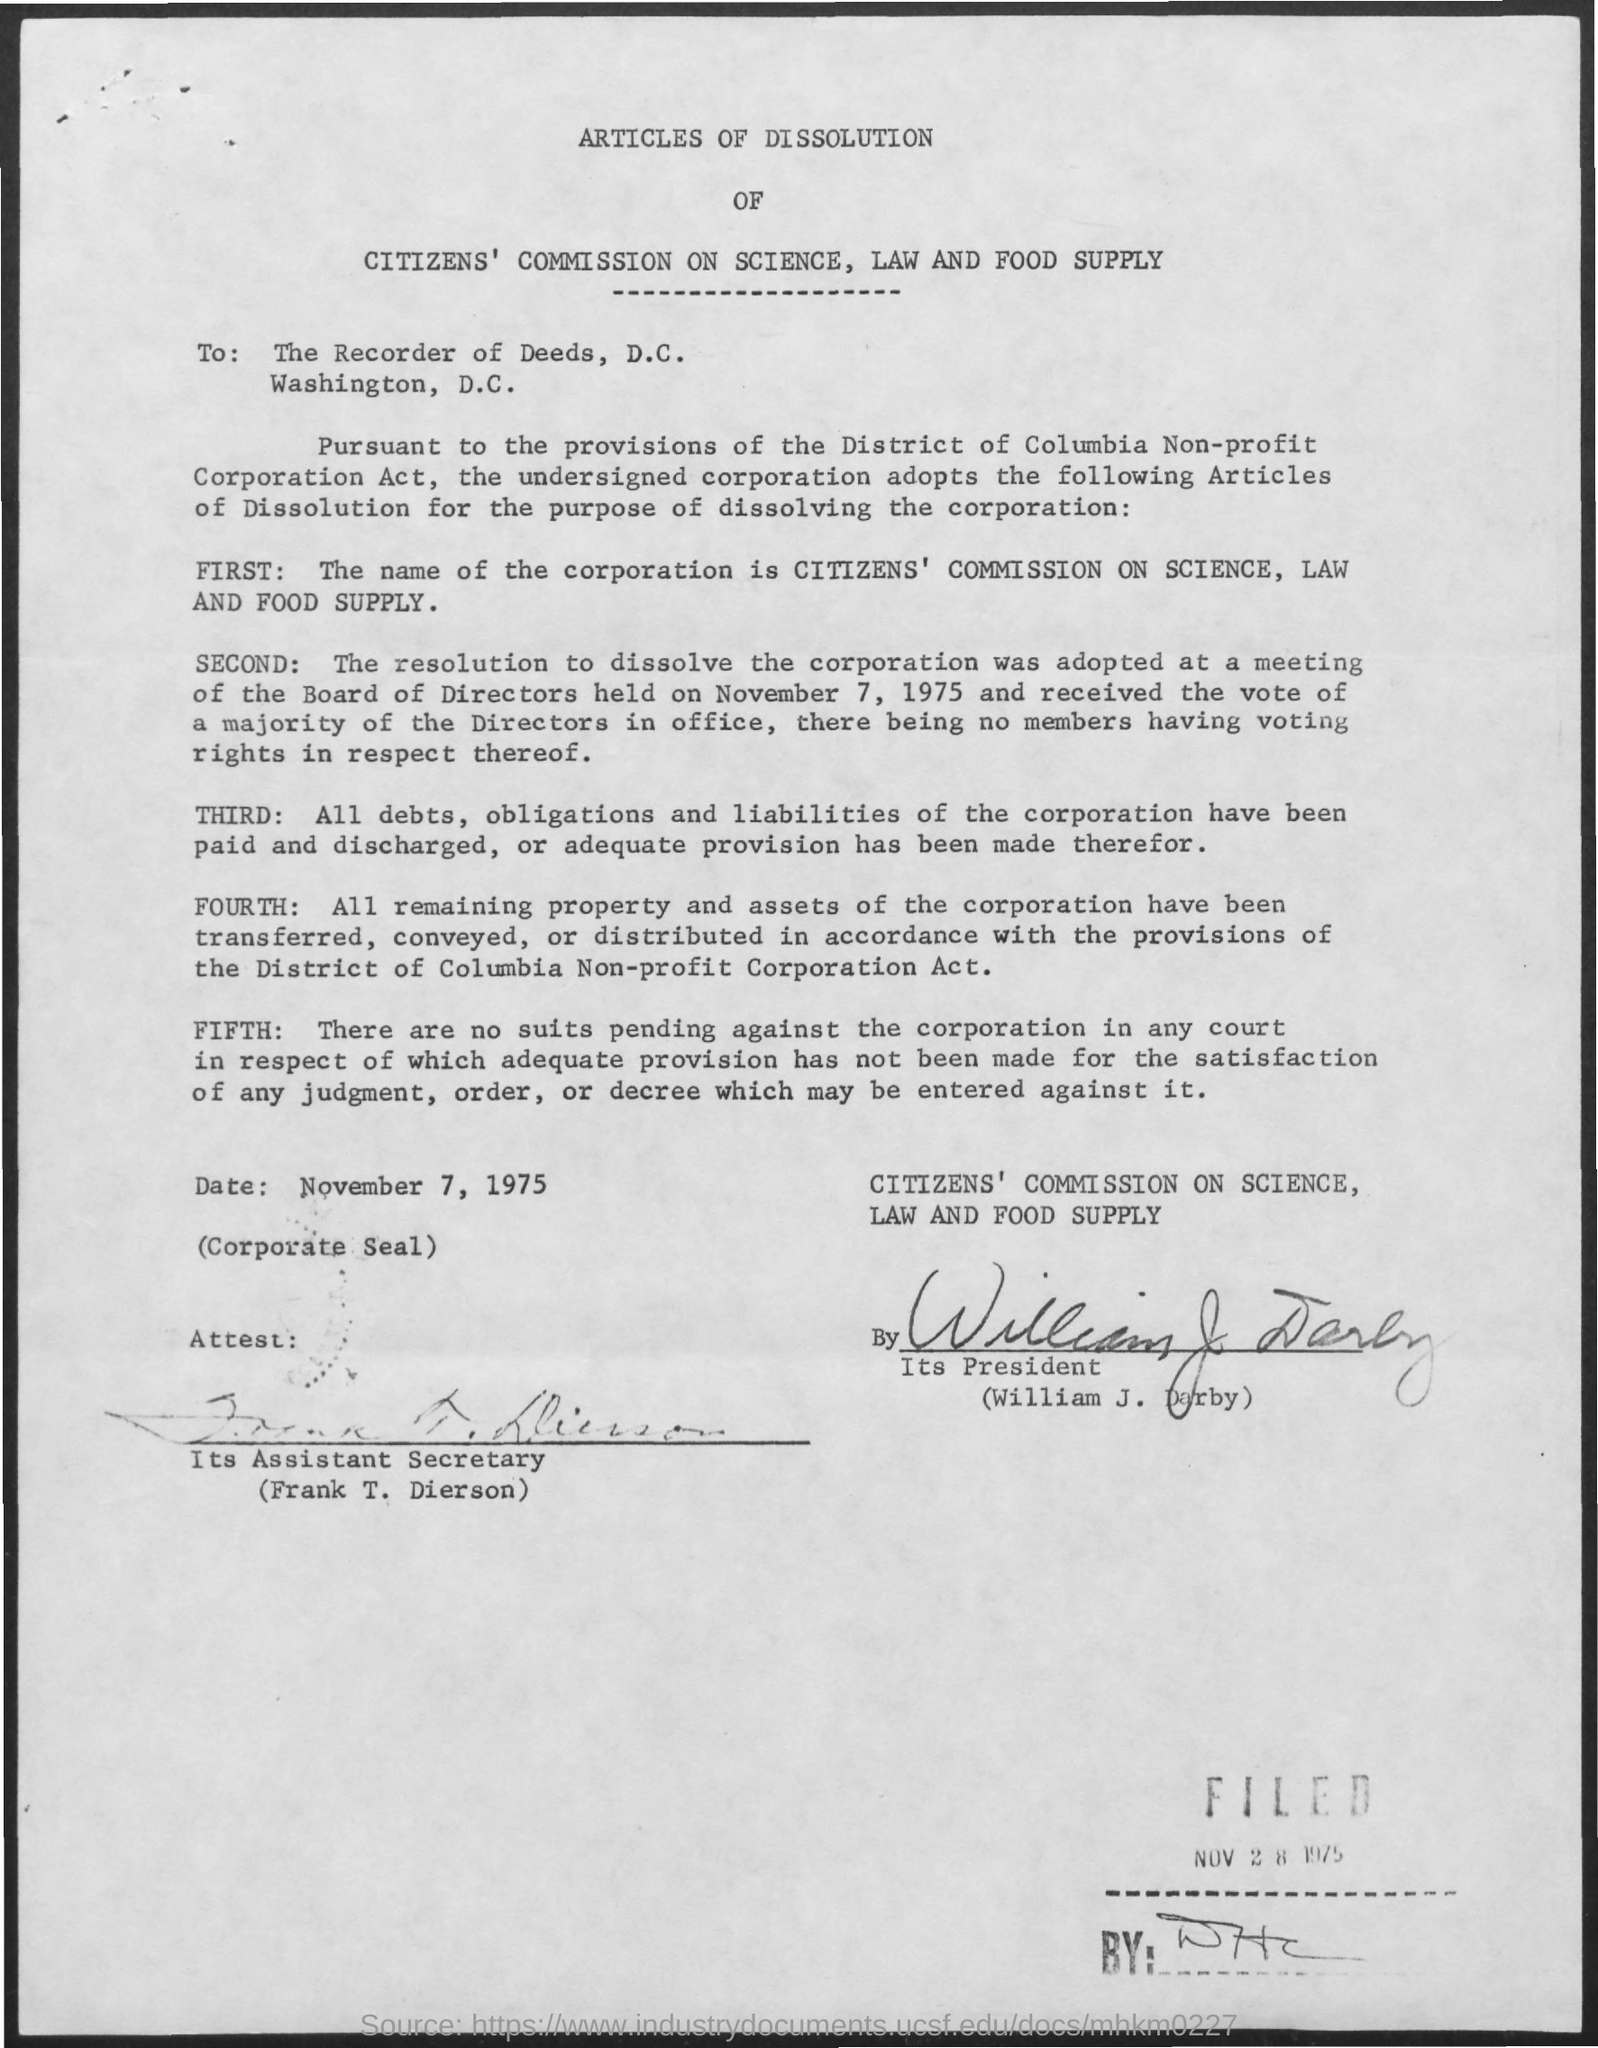Who has signed the document?
Make the answer very short. William J. Darby. To whom, the document is addressed?
Offer a terse response. THE RECORDER OF DEEDS. 